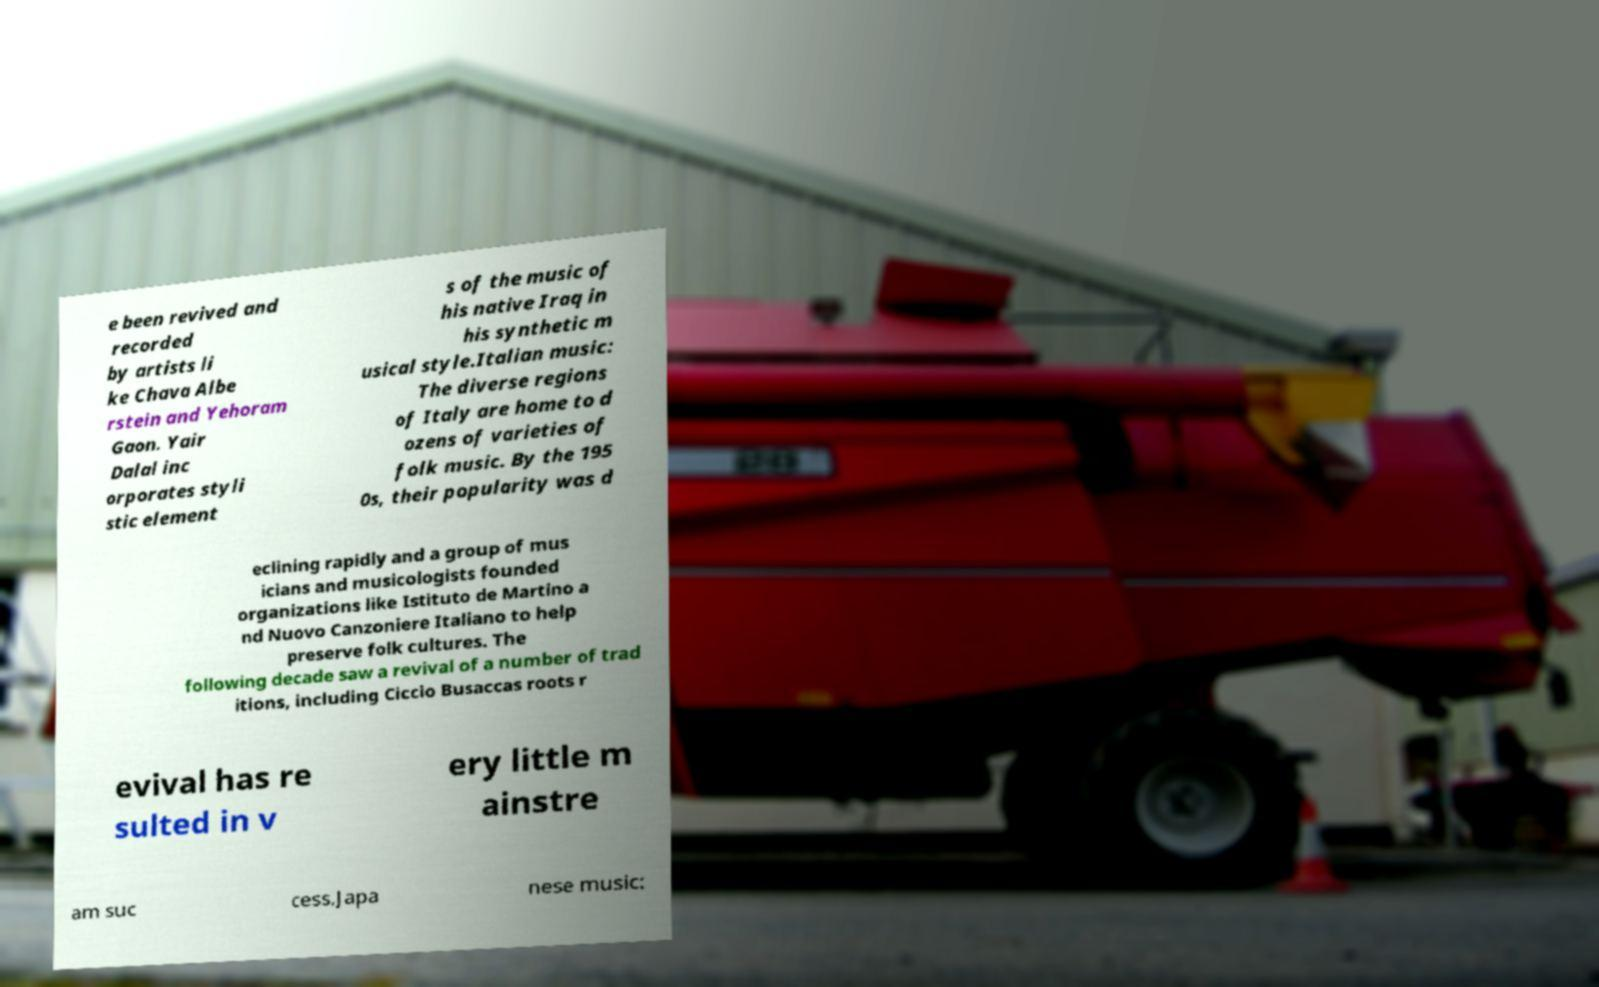For documentation purposes, I need the text within this image transcribed. Could you provide that? e been revived and recorded by artists li ke Chava Albe rstein and Yehoram Gaon. Yair Dalal inc orporates styli stic element s of the music of his native Iraq in his synthetic m usical style.Italian music: The diverse regions of Italy are home to d ozens of varieties of folk music. By the 195 0s, their popularity was d eclining rapidly and a group of mus icians and musicologists founded organizations like Istituto de Martino a nd Nuovo Canzoniere Italiano to help preserve folk cultures. The following decade saw a revival of a number of trad itions, including Ciccio Busaccas roots r evival has re sulted in v ery little m ainstre am suc cess.Japa nese music: 